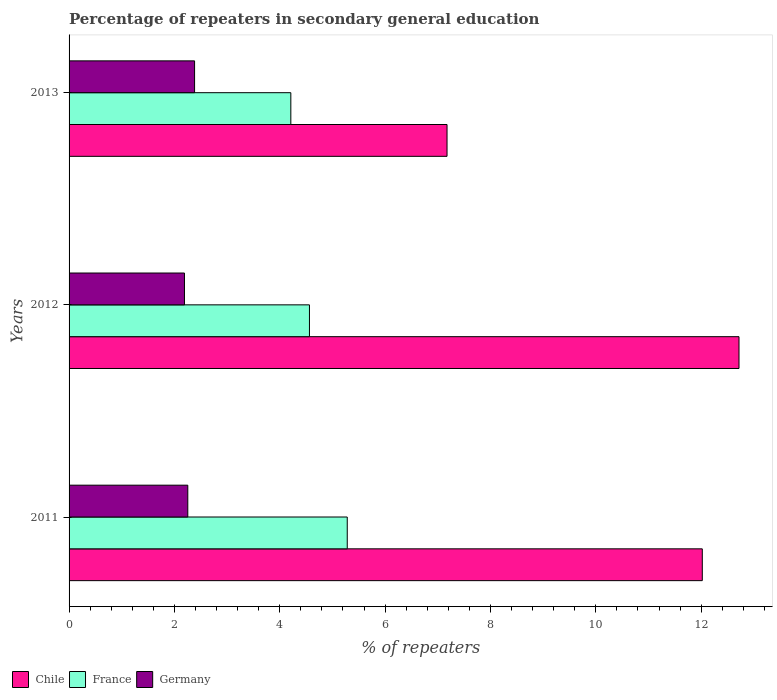How many groups of bars are there?
Keep it short and to the point. 3. Are the number of bars per tick equal to the number of legend labels?
Offer a very short reply. Yes. How many bars are there on the 1st tick from the bottom?
Your answer should be very brief. 3. What is the label of the 3rd group of bars from the top?
Your response must be concise. 2011. In how many cases, is the number of bars for a given year not equal to the number of legend labels?
Offer a very short reply. 0. What is the percentage of repeaters in secondary general education in Germany in 2013?
Make the answer very short. 2.38. Across all years, what is the maximum percentage of repeaters in secondary general education in Germany?
Your answer should be very brief. 2.38. Across all years, what is the minimum percentage of repeaters in secondary general education in Chile?
Make the answer very short. 7.18. In which year was the percentage of repeaters in secondary general education in Chile maximum?
Your response must be concise. 2012. In which year was the percentage of repeaters in secondary general education in France minimum?
Offer a terse response. 2013. What is the total percentage of repeaters in secondary general education in Chile in the graph?
Provide a succinct answer. 31.91. What is the difference between the percentage of repeaters in secondary general education in Germany in 2011 and that in 2013?
Keep it short and to the point. -0.13. What is the difference between the percentage of repeaters in secondary general education in Chile in 2011 and the percentage of repeaters in secondary general education in France in 2012?
Your response must be concise. 7.46. What is the average percentage of repeaters in secondary general education in Chile per year?
Make the answer very short. 10.64. In the year 2013, what is the difference between the percentage of repeaters in secondary general education in Chile and percentage of repeaters in secondary general education in France?
Provide a succinct answer. 2.97. In how many years, is the percentage of repeaters in secondary general education in Germany greater than 6.8 %?
Your answer should be very brief. 0. What is the ratio of the percentage of repeaters in secondary general education in Germany in 2012 to that in 2013?
Ensure brevity in your answer.  0.92. Is the percentage of repeaters in secondary general education in Chile in 2011 less than that in 2013?
Ensure brevity in your answer.  No. Is the difference between the percentage of repeaters in secondary general education in Chile in 2011 and 2012 greater than the difference between the percentage of repeaters in secondary general education in France in 2011 and 2012?
Your answer should be very brief. No. What is the difference between the highest and the second highest percentage of repeaters in secondary general education in Germany?
Provide a short and direct response. 0.13. What is the difference between the highest and the lowest percentage of repeaters in secondary general education in Germany?
Keep it short and to the point. 0.19. In how many years, is the percentage of repeaters in secondary general education in Germany greater than the average percentage of repeaters in secondary general education in Germany taken over all years?
Your answer should be very brief. 1. What does the 2nd bar from the bottom in 2012 represents?
Your answer should be compact. France. Is it the case that in every year, the sum of the percentage of repeaters in secondary general education in Germany and percentage of repeaters in secondary general education in Chile is greater than the percentage of repeaters in secondary general education in France?
Your answer should be compact. Yes. How many bars are there?
Offer a very short reply. 9. Are all the bars in the graph horizontal?
Offer a very short reply. Yes. Are the values on the major ticks of X-axis written in scientific E-notation?
Make the answer very short. No. Does the graph contain any zero values?
Keep it short and to the point. No. How many legend labels are there?
Ensure brevity in your answer.  3. How are the legend labels stacked?
Offer a terse response. Horizontal. What is the title of the graph?
Ensure brevity in your answer.  Percentage of repeaters in secondary general education. What is the label or title of the X-axis?
Provide a succinct answer. % of repeaters. What is the % of repeaters of Chile in 2011?
Provide a short and direct response. 12.02. What is the % of repeaters in France in 2011?
Give a very brief answer. 5.28. What is the % of repeaters in Germany in 2011?
Your response must be concise. 2.25. What is the % of repeaters in Chile in 2012?
Make the answer very short. 12.72. What is the % of repeaters of France in 2012?
Offer a very short reply. 4.56. What is the % of repeaters of Germany in 2012?
Your answer should be very brief. 2.19. What is the % of repeaters of Chile in 2013?
Offer a terse response. 7.18. What is the % of repeaters in France in 2013?
Your response must be concise. 4.21. What is the % of repeaters of Germany in 2013?
Offer a terse response. 2.38. Across all years, what is the maximum % of repeaters of Chile?
Make the answer very short. 12.72. Across all years, what is the maximum % of repeaters of France?
Offer a very short reply. 5.28. Across all years, what is the maximum % of repeaters of Germany?
Give a very brief answer. 2.38. Across all years, what is the minimum % of repeaters in Chile?
Keep it short and to the point. 7.18. Across all years, what is the minimum % of repeaters in France?
Ensure brevity in your answer.  4.21. Across all years, what is the minimum % of repeaters in Germany?
Offer a very short reply. 2.19. What is the total % of repeaters in Chile in the graph?
Keep it short and to the point. 31.91. What is the total % of repeaters in France in the graph?
Offer a terse response. 14.05. What is the total % of repeaters of Germany in the graph?
Make the answer very short. 6.83. What is the difference between the % of repeaters of Chile in 2011 and that in 2012?
Your answer should be very brief. -0.7. What is the difference between the % of repeaters of France in 2011 and that in 2012?
Provide a succinct answer. 0.72. What is the difference between the % of repeaters in Germany in 2011 and that in 2012?
Your response must be concise. 0.06. What is the difference between the % of repeaters in Chile in 2011 and that in 2013?
Your answer should be very brief. 4.85. What is the difference between the % of repeaters in France in 2011 and that in 2013?
Your response must be concise. 1.07. What is the difference between the % of repeaters of Germany in 2011 and that in 2013?
Keep it short and to the point. -0.13. What is the difference between the % of repeaters of Chile in 2012 and that in 2013?
Your answer should be compact. 5.54. What is the difference between the % of repeaters in France in 2012 and that in 2013?
Make the answer very short. 0.35. What is the difference between the % of repeaters in Germany in 2012 and that in 2013?
Make the answer very short. -0.19. What is the difference between the % of repeaters in Chile in 2011 and the % of repeaters in France in 2012?
Offer a very short reply. 7.46. What is the difference between the % of repeaters in Chile in 2011 and the % of repeaters in Germany in 2012?
Your answer should be very brief. 9.83. What is the difference between the % of repeaters in France in 2011 and the % of repeaters in Germany in 2012?
Keep it short and to the point. 3.09. What is the difference between the % of repeaters in Chile in 2011 and the % of repeaters in France in 2013?
Keep it short and to the point. 7.81. What is the difference between the % of repeaters in Chile in 2011 and the % of repeaters in Germany in 2013?
Ensure brevity in your answer.  9.64. What is the difference between the % of repeaters of France in 2011 and the % of repeaters of Germany in 2013?
Offer a very short reply. 2.9. What is the difference between the % of repeaters in Chile in 2012 and the % of repeaters in France in 2013?
Provide a succinct answer. 8.51. What is the difference between the % of repeaters in Chile in 2012 and the % of repeaters in Germany in 2013?
Provide a short and direct response. 10.34. What is the difference between the % of repeaters of France in 2012 and the % of repeaters of Germany in 2013?
Keep it short and to the point. 2.18. What is the average % of repeaters of Chile per year?
Your answer should be very brief. 10.64. What is the average % of repeaters in France per year?
Keep it short and to the point. 4.68. What is the average % of repeaters of Germany per year?
Your answer should be very brief. 2.28. In the year 2011, what is the difference between the % of repeaters of Chile and % of repeaters of France?
Keep it short and to the point. 6.74. In the year 2011, what is the difference between the % of repeaters of Chile and % of repeaters of Germany?
Make the answer very short. 9.77. In the year 2011, what is the difference between the % of repeaters of France and % of repeaters of Germany?
Your response must be concise. 3.03. In the year 2012, what is the difference between the % of repeaters in Chile and % of repeaters in France?
Offer a terse response. 8.15. In the year 2012, what is the difference between the % of repeaters in Chile and % of repeaters in Germany?
Give a very brief answer. 10.53. In the year 2012, what is the difference between the % of repeaters of France and % of repeaters of Germany?
Ensure brevity in your answer.  2.37. In the year 2013, what is the difference between the % of repeaters of Chile and % of repeaters of France?
Ensure brevity in your answer.  2.97. In the year 2013, what is the difference between the % of repeaters of Chile and % of repeaters of Germany?
Keep it short and to the point. 4.79. In the year 2013, what is the difference between the % of repeaters of France and % of repeaters of Germany?
Provide a succinct answer. 1.83. What is the ratio of the % of repeaters of Chile in 2011 to that in 2012?
Give a very brief answer. 0.95. What is the ratio of the % of repeaters in France in 2011 to that in 2012?
Give a very brief answer. 1.16. What is the ratio of the % of repeaters of Germany in 2011 to that in 2012?
Provide a short and direct response. 1.03. What is the ratio of the % of repeaters of Chile in 2011 to that in 2013?
Provide a short and direct response. 1.68. What is the ratio of the % of repeaters of France in 2011 to that in 2013?
Your answer should be very brief. 1.25. What is the ratio of the % of repeaters of Germany in 2011 to that in 2013?
Make the answer very short. 0.95. What is the ratio of the % of repeaters of Chile in 2012 to that in 2013?
Your answer should be compact. 1.77. What is the ratio of the % of repeaters of France in 2012 to that in 2013?
Offer a terse response. 1.08. What is the ratio of the % of repeaters of Germany in 2012 to that in 2013?
Provide a succinct answer. 0.92. What is the difference between the highest and the second highest % of repeaters in Chile?
Ensure brevity in your answer.  0.7. What is the difference between the highest and the second highest % of repeaters of France?
Make the answer very short. 0.72. What is the difference between the highest and the second highest % of repeaters in Germany?
Make the answer very short. 0.13. What is the difference between the highest and the lowest % of repeaters of Chile?
Your answer should be compact. 5.54. What is the difference between the highest and the lowest % of repeaters of France?
Offer a terse response. 1.07. What is the difference between the highest and the lowest % of repeaters of Germany?
Provide a short and direct response. 0.19. 